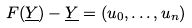<formula> <loc_0><loc_0><loc_500><loc_500>F ( \underline { Y } ) - \underline { Y } = ( u _ { 0 } , \dots , u _ { n } )</formula> 